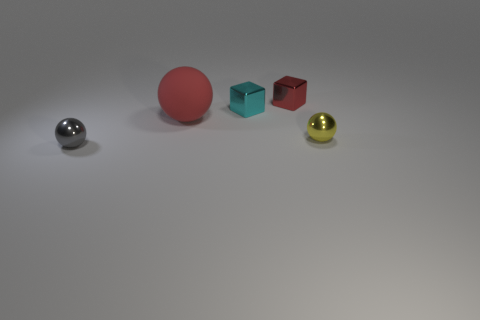Add 5 small red rubber cylinders. How many objects exist? 10 Subtract all blocks. How many objects are left? 3 Add 4 tiny gray spheres. How many tiny gray spheres exist? 5 Subtract 0 purple cylinders. How many objects are left? 5 Subtract all cyan objects. Subtract all tiny things. How many objects are left? 0 Add 1 tiny balls. How many tiny balls are left? 3 